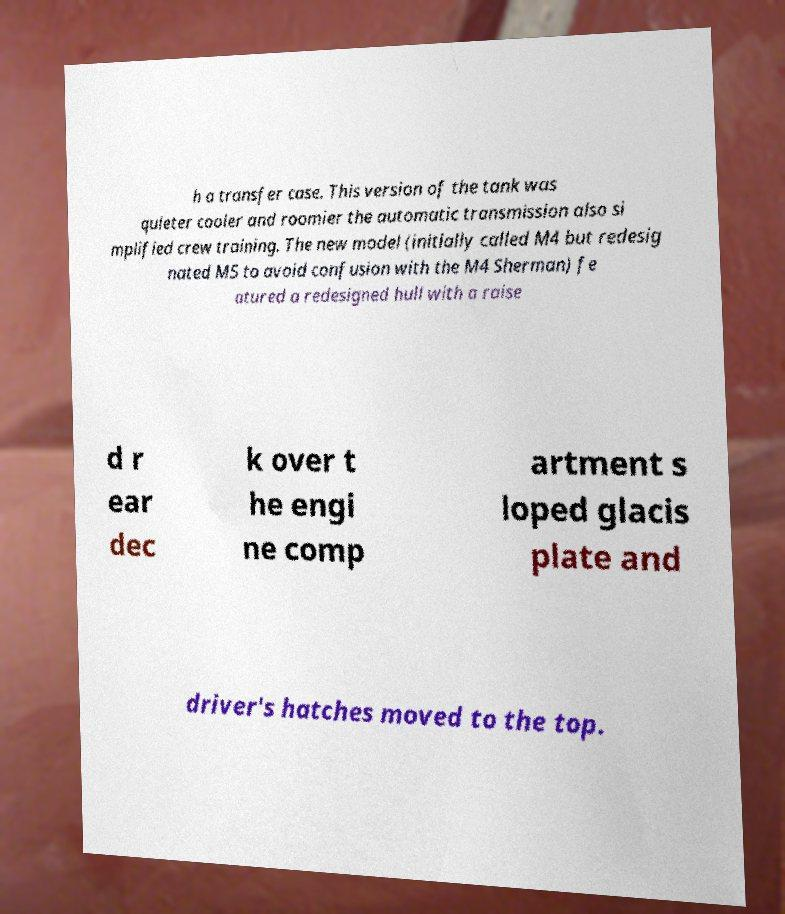Could you extract and type out the text from this image? h a transfer case. This version of the tank was quieter cooler and roomier the automatic transmission also si mplified crew training. The new model (initially called M4 but redesig nated M5 to avoid confusion with the M4 Sherman) fe atured a redesigned hull with a raise d r ear dec k over t he engi ne comp artment s loped glacis plate and driver's hatches moved to the top. 